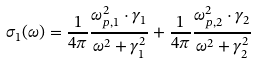Convert formula to latex. <formula><loc_0><loc_0><loc_500><loc_500>\sigma _ { 1 } ( \omega ) = \frac { 1 } { 4 \pi } \frac { \omega _ { p , 1 } ^ { 2 } \cdot \gamma _ { 1 } } { \omega ^ { 2 } + \gamma _ { 1 } ^ { 2 } } + \frac { 1 } { 4 \pi } \frac { \omega _ { p , 2 } ^ { 2 } \cdot \gamma _ { 2 } } { \omega ^ { 2 } + \gamma _ { 2 } ^ { 2 } }</formula> 